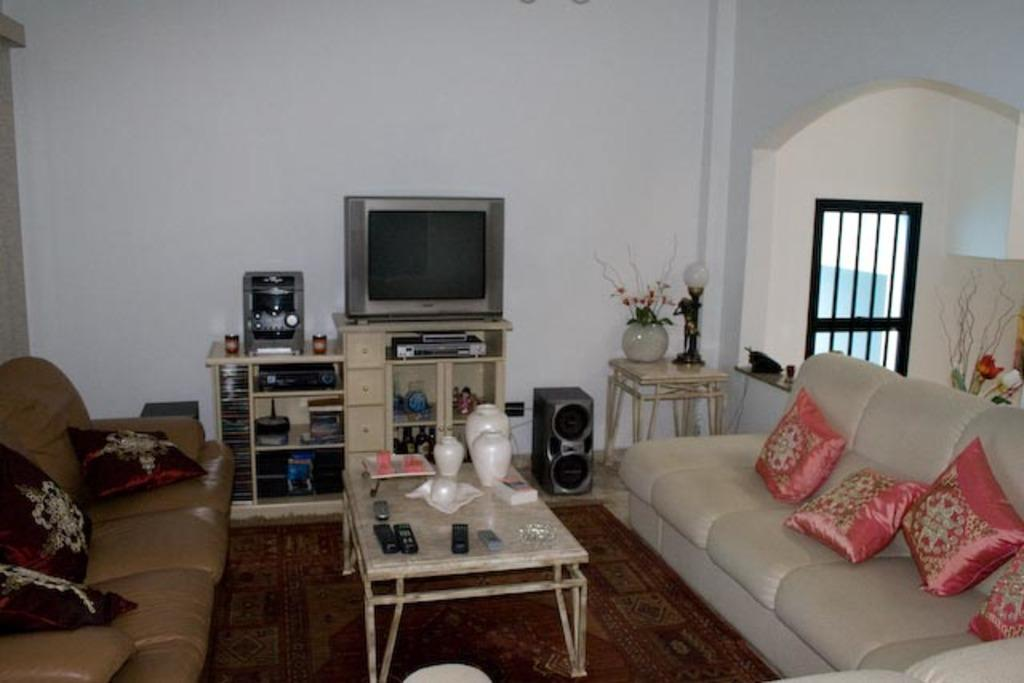What type of furniture is present in the image? There are sofas with pillows in the image. What type of floor covering is visible in the image? There is a carpet in the image. What type of surface is present for placing objects? There are tables in the image. What type of decorative objects can be seen in the image? There are vases in the image. What type of device is present for controlling electronics? There are remotes in the image. What type of entertainment device is present in the image? There is a television in the image. What type of audio equipment is present in the image? There are speakers in the image. What type of architectural feature is present for natural light and viewing the outdoors? There is a window in the image. What type of background is visible in the image? The wall is visible in the background of the image. What type of bone is visible in the image? There is no bone present in the image. What type of account is being discussed in the image? There is no account being discussed in the image. 